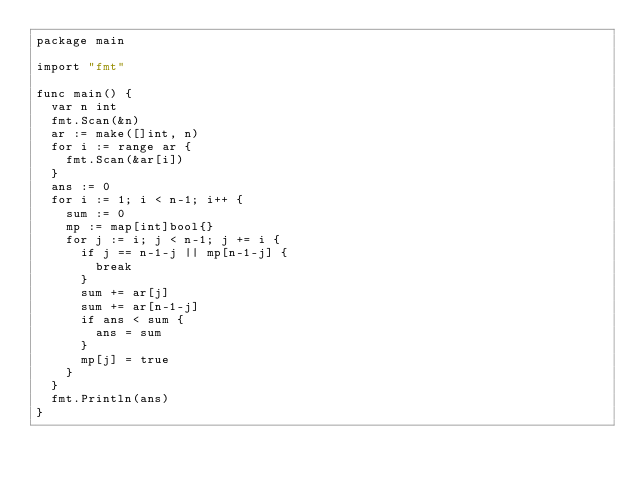<code> <loc_0><loc_0><loc_500><loc_500><_Go_>package main

import "fmt"

func main() {
	var n int
	fmt.Scan(&n)
	ar := make([]int, n)
	for i := range ar {
		fmt.Scan(&ar[i])
	}
	ans := 0
	for i := 1; i < n-1; i++ {
		sum := 0
		mp := map[int]bool{}
		for j := i; j < n-1; j += i {
			if j == n-1-j || mp[n-1-j] {
				break
			}
			sum += ar[j]
			sum += ar[n-1-j]
			if ans < sum {
				ans = sum
			}
			mp[j] = true
		}
	}
	fmt.Println(ans)
}
</code> 